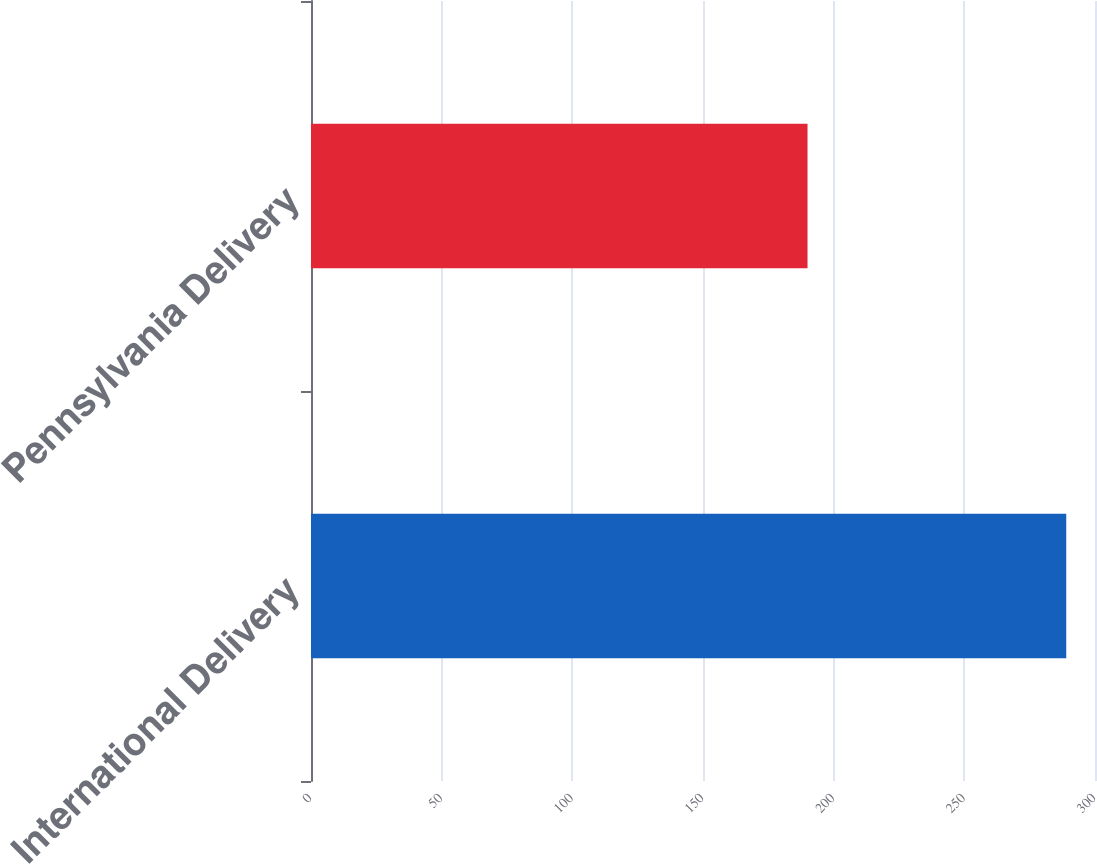Convert chart. <chart><loc_0><loc_0><loc_500><loc_500><bar_chart><fcel>International Delivery<fcel>Pennsylvania Delivery<nl><fcel>289<fcel>190<nl></chart> 